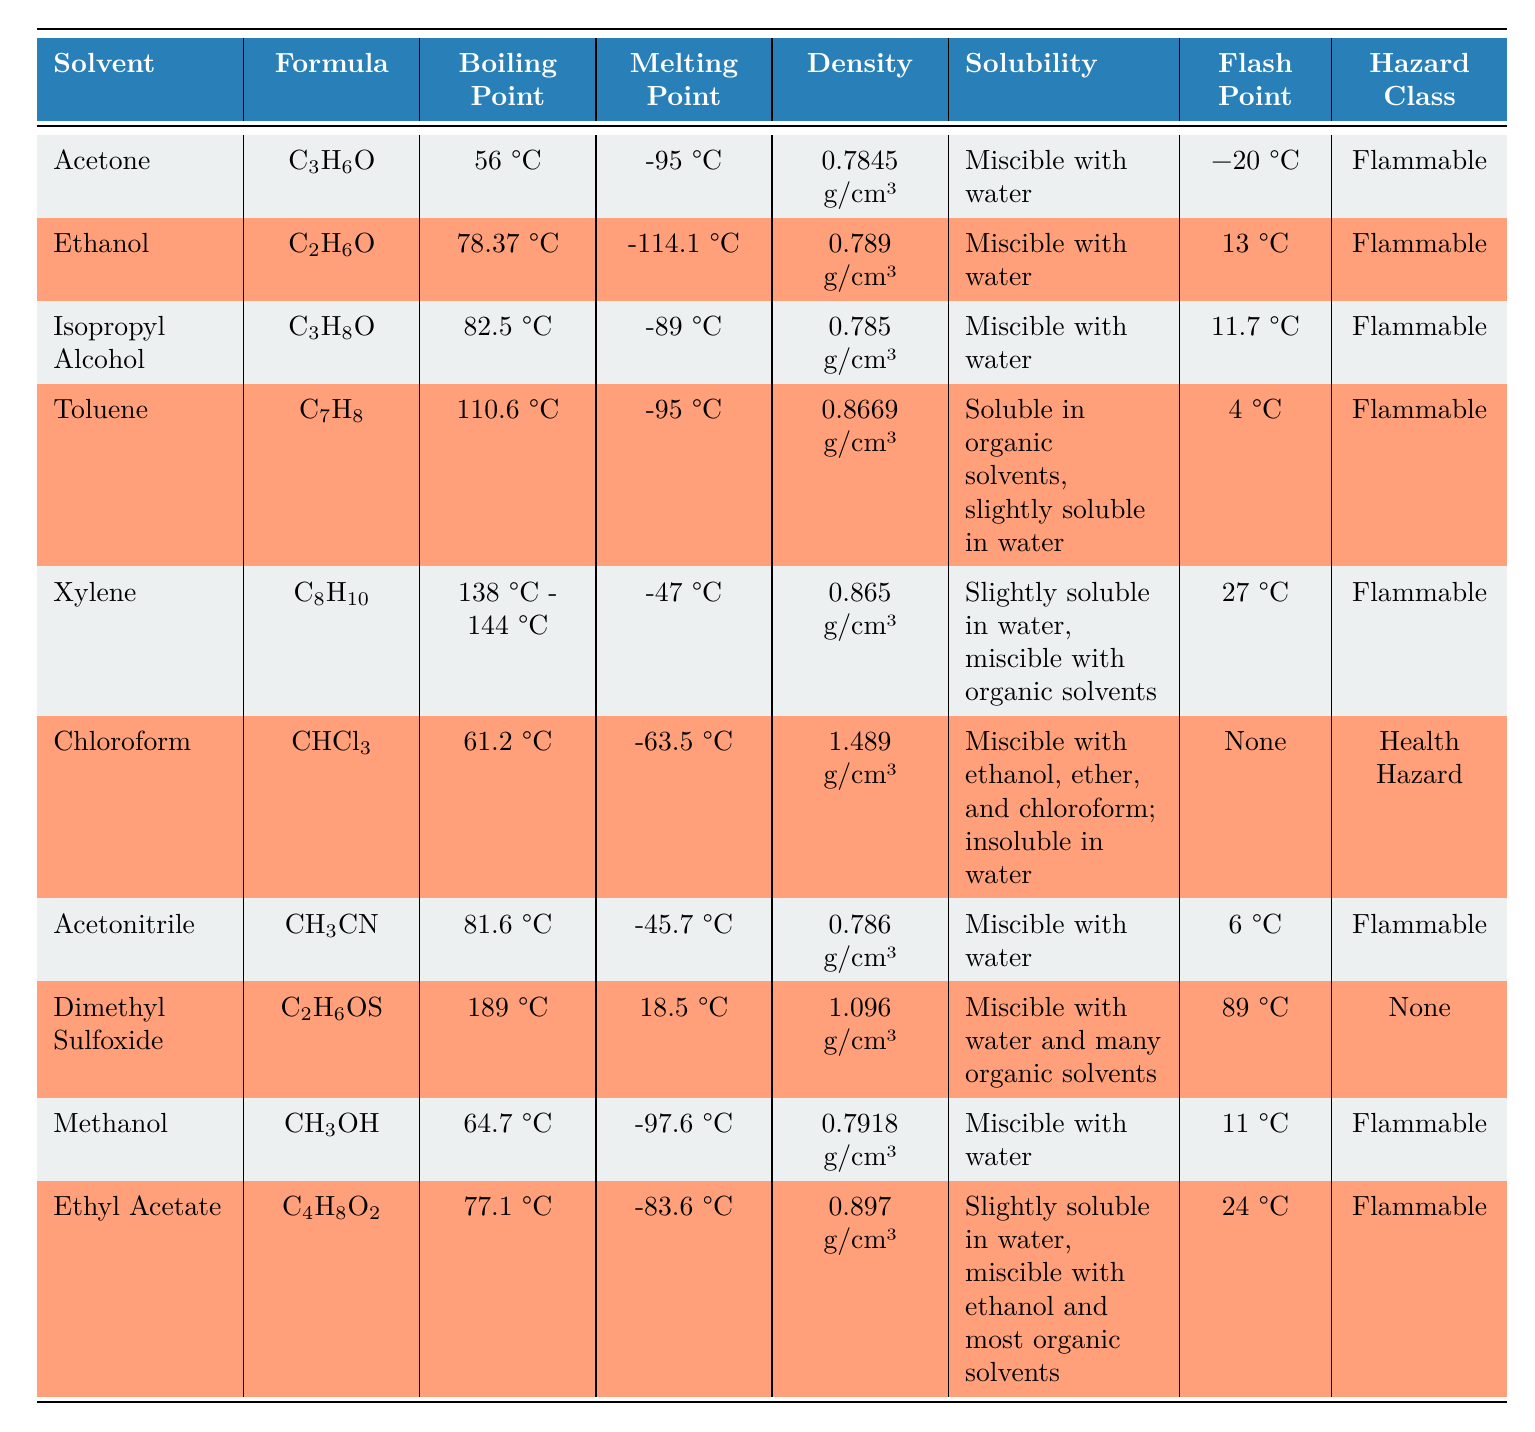What is the boiling point of Acetone? The boiling point for Acetone is listed in the table under the "Boiling Point" column. It shows a value of 56 °C.
Answer: 56 °C Which solvent has the highest density? To find the highest density, we can compare the density values in the "Density" column. The highest value is 1.489 g/cm³ for Chloroform.
Answer: 1.489 g/cm³ (Chloroform) Is Ethanol flammable? Ethanol's hazard class is mentioned as "Flammable" in the table, which indicates it is indeed flammable.
Answer: Yes What is the average boiling point of the solvents listed? The boiling points are: 56 °C (Acetone), 78.37 °C (Ethanol), 82.5 °C (Isopropyl Alcohol), 110.6 °C (Toluene), 141 °C (average of Xylene), 61.2 °C (Chloroform), 81.6 °C (Acetonitrile), 189 °C (Dimethyl Sulfoxide), 64.7 °C (Methanol), and 77.1 °C (Ethyl Acetate). Adding these values gives a total of  826.47 °C, which divided by 10 (number of solvents) results in an average of approximately 82.65 °C.
Answer: 82.65 °C Which solvents are miscible with water? By reviewing the "Solubility" column, we identify that Acetone, Ethanol, Isopropyl Alcohol, Acetonitrile, Methanol, and Dimethyl Sulfoxide are all miscible with water, as stated in their solubility information.
Answer: Acetone, Ethanol, Isopropyl Alcohol, Acetonitrile, Methanol, Dimethyl Sulfoxide What is the flash point of Toluene? The flash point for Toluene is provided in the "Flash Point" column, showing a value of 4 °C.
Answer: 4 °C 